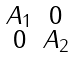Convert formula to latex. <formula><loc_0><loc_0><loc_500><loc_500>\begin{smallmatrix} A _ { 1 } & 0 \\ 0 & A _ { 2 } \end{smallmatrix}</formula> 